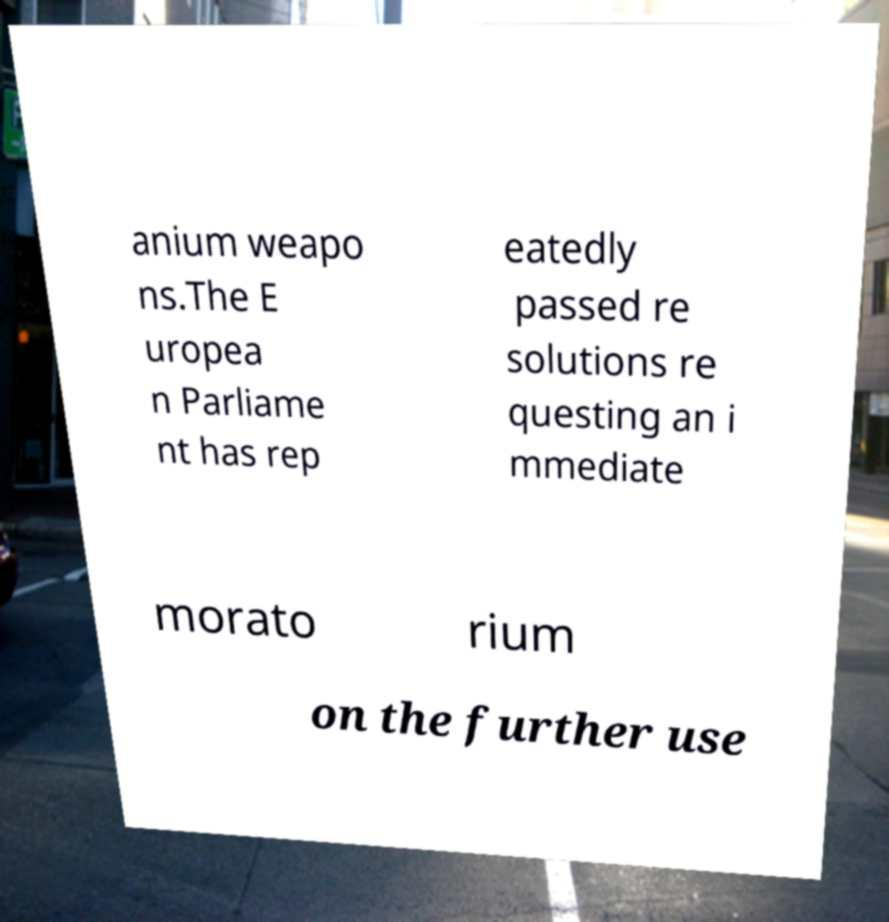For documentation purposes, I need the text within this image transcribed. Could you provide that? anium weapo ns.The E uropea n Parliame nt has rep eatedly passed re solutions re questing an i mmediate morato rium on the further use 